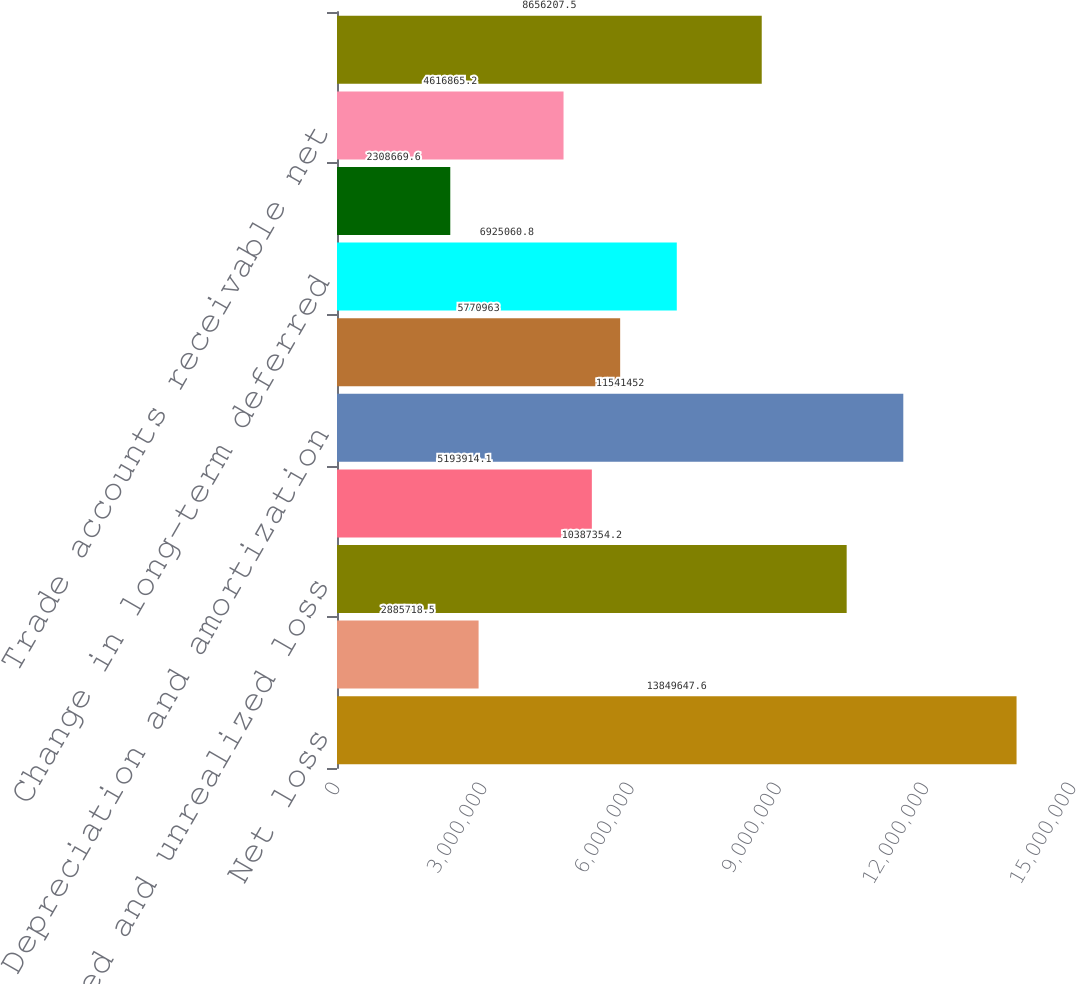<chart> <loc_0><loc_0><loc_500><loc_500><bar_chart><fcel>Net loss<fcel>Equity in losses of affiliates<fcel>Realized and unrealized loss<fcel>Deferred stock-based<fcel>Depreciation and amortization<fcel>Amortization of debt discount<fcel>Change in long-term deferred<fcel>Other net<fcel>Trade accounts receivable net<fcel>Inventories<nl><fcel>1.38496e+07<fcel>2.88572e+06<fcel>1.03874e+07<fcel>5.19391e+06<fcel>1.15415e+07<fcel>5.77096e+06<fcel>6.92506e+06<fcel>2.30867e+06<fcel>4.61687e+06<fcel>8.65621e+06<nl></chart> 